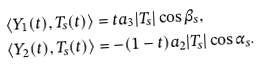<formula> <loc_0><loc_0><loc_500><loc_500>& \langle Y _ { 1 } ( t ) , T _ { s } ( t ) \rangle = t a _ { 3 } | T _ { s } | \cos \beta _ { s } , \, \\ & \langle Y _ { 2 } ( t ) , T _ { s } ( t ) \rangle = - ( 1 - t ) a _ { 2 } | T _ { s } | \cos \alpha _ { s } .</formula> 